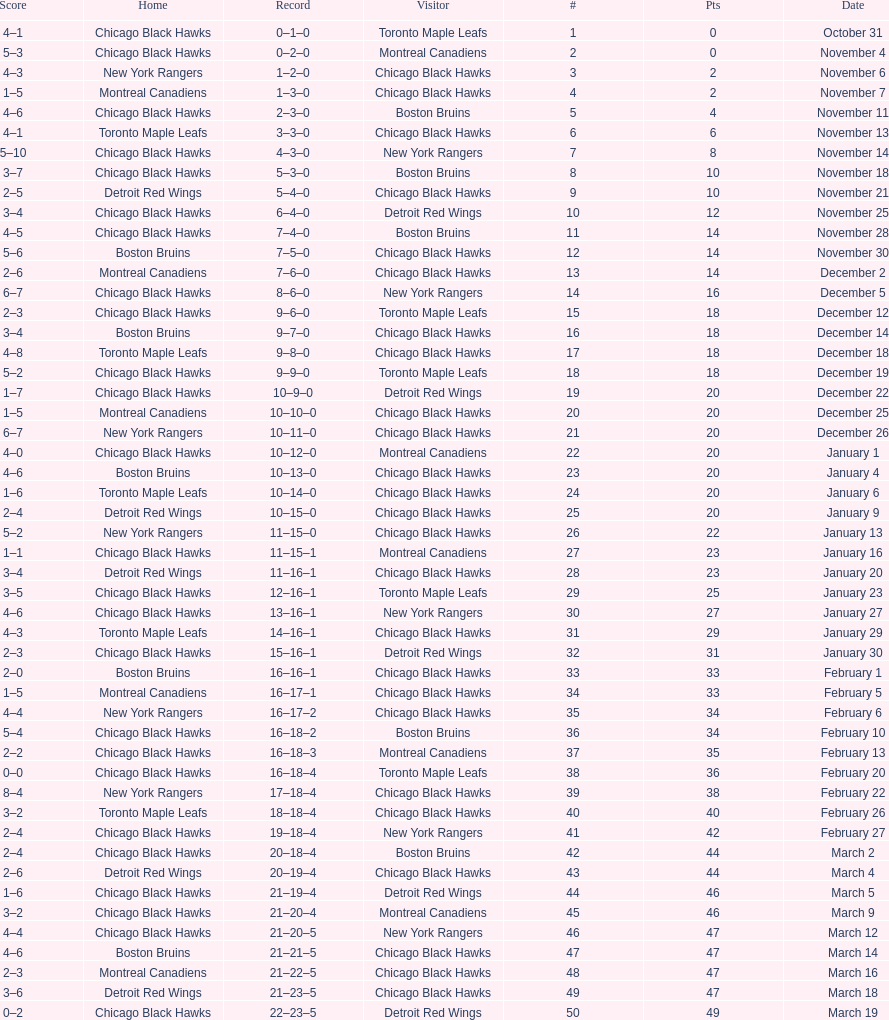Tell me the number of points the blackhawks had on march 4. 44. 